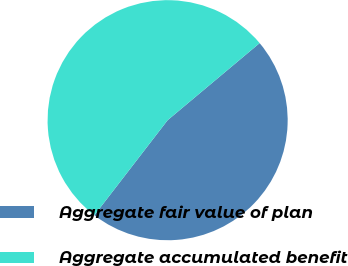<chart> <loc_0><loc_0><loc_500><loc_500><pie_chart><fcel>Aggregate fair value of plan<fcel>Aggregate accumulated benefit<nl><fcel>46.55%<fcel>53.45%<nl></chart> 